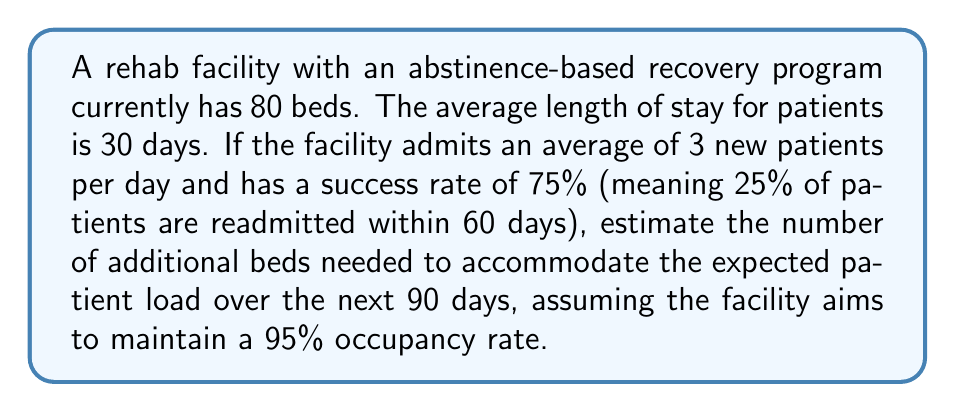Help me with this question. Let's approach this step-by-step:

1) First, calculate the number of patients admitted in 90 days:
   $$ \text{New admissions} = 90 \text{ days} \times 3 \text{ patients/day} = 270 \text{ patients} $$

2) Calculate the number of readmissions:
   $$ \text{Readmissions} = 270 \times 25\% = 67.5 \text{ patients} $$

3) Total admissions over 90 days:
   $$ \text{Total admissions} = 270 + 67.5 = 337.5 \text{ patients} $$

4) Calculate the average daily patient load:
   $$ \text{Average daily load} = \frac{337.5 \text{ patients} \times 30 \text{ days}}{90 \text{ days}} = 112.5 \text{ patients} $$

5) Calculate the number of beds needed for 95% occupancy:
   $$ \text{Beds needed} = \frac{112.5}{0.95} \approx 118.42 \text{ beds} $$

6) Calculate additional beds needed:
   $$ \text{Additional beds} = 118.42 - 80 \text{ (current beds)} = 38.42 \text{ beds} $$

7) Round up to the nearest whole number:
   $$ \text{Additional beds needed} = 39 \text{ beds} $$
Answer: 39 beds 